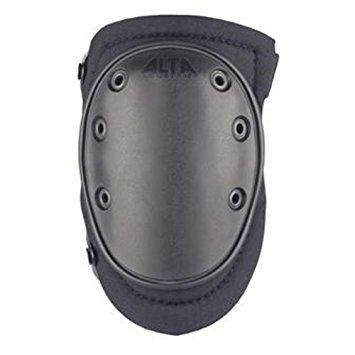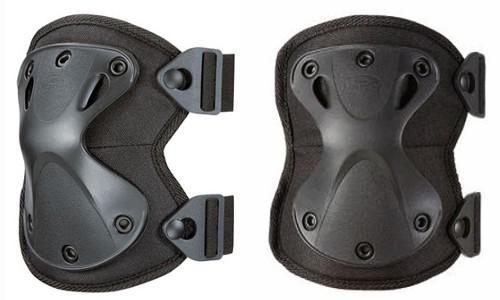The first image is the image on the left, the second image is the image on the right. Assess this claim about the two images: "The left image contains one kneepad, while the right image contains a pair.". Correct or not? Answer yes or no. Yes. The first image is the image on the left, the second image is the image on the right. Evaluate the accuracy of this statement regarding the images: "There are three greyish colored pads.". Is it true? Answer yes or no. Yes. 